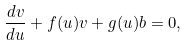<formula> <loc_0><loc_0><loc_500><loc_500>\frac { d v } { d u } + f ( u ) v + g ( u ) b = 0 ,</formula> 